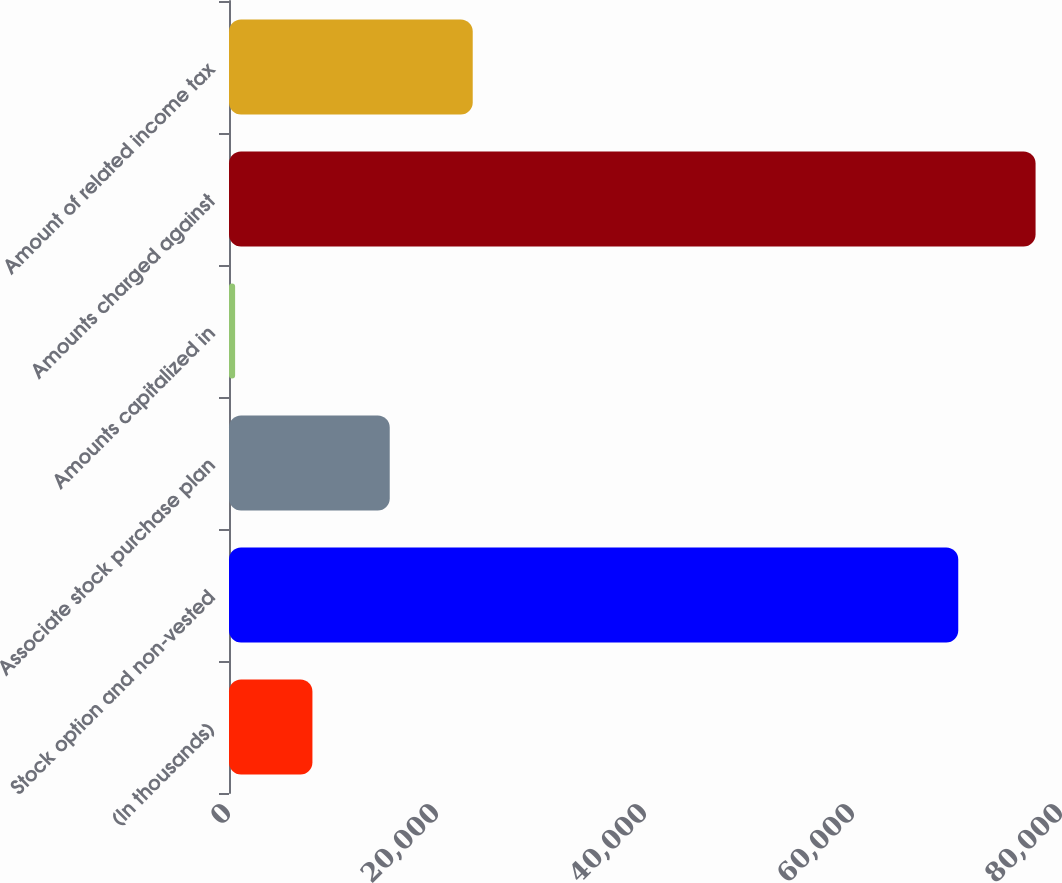Convert chart. <chart><loc_0><loc_0><loc_500><loc_500><bar_chart><fcel>(In thousands)<fcel>Stock option and non-vested<fcel>Associate stock purchase plan<fcel>Amounts capitalized in<fcel>Amounts charged against<fcel>Amount of related income tax<nl><fcel>8021.8<fcel>70121<fcel>15455.6<fcel>588<fcel>77554.8<fcel>23435<nl></chart> 